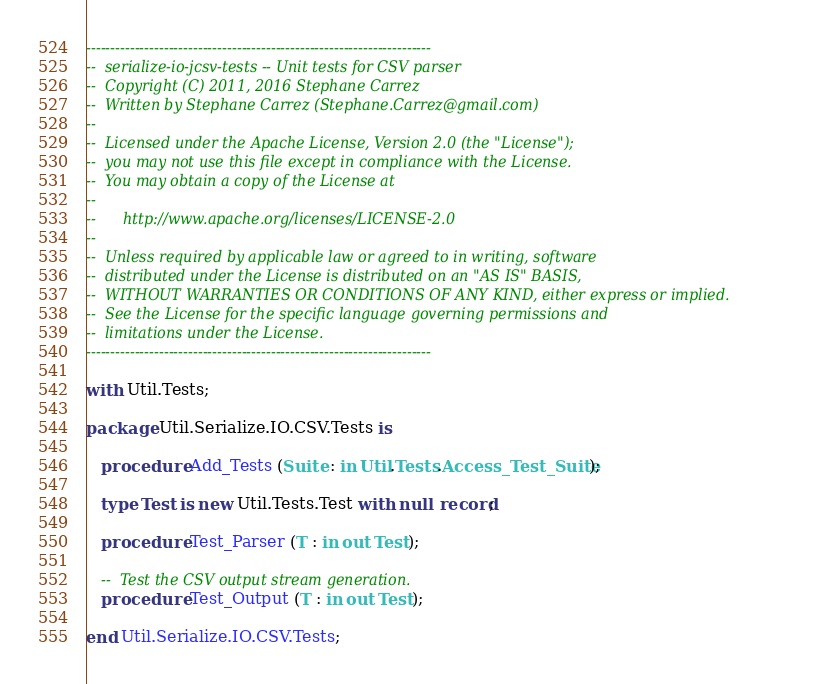<code> <loc_0><loc_0><loc_500><loc_500><_Ada_>-----------------------------------------------------------------------
--  serialize-io-jcsv-tests -- Unit tests for CSV parser
--  Copyright (C) 2011, 2016 Stephane Carrez
--  Written by Stephane Carrez (Stephane.Carrez@gmail.com)
--
--  Licensed under the Apache License, Version 2.0 (the "License");
--  you may not use this file except in compliance with the License.
--  You may obtain a copy of the License at
--
--      http://www.apache.org/licenses/LICENSE-2.0
--
--  Unless required by applicable law or agreed to in writing, software
--  distributed under the License is distributed on an "AS IS" BASIS,
--  WITHOUT WARRANTIES OR CONDITIONS OF ANY KIND, either express or implied.
--  See the License for the specific language governing permissions and
--  limitations under the License.
-----------------------------------------------------------------------

with Util.Tests;

package Util.Serialize.IO.CSV.Tests is

   procedure Add_Tests (Suite : in Util.Tests.Access_Test_Suite);

   type Test is new Util.Tests.Test with null record;

   procedure Test_Parser (T : in out Test);

   --  Test the CSV output stream generation.
   procedure Test_Output (T : in out Test);

end Util.Serialize.IO.CSV.Tests;
</code> 